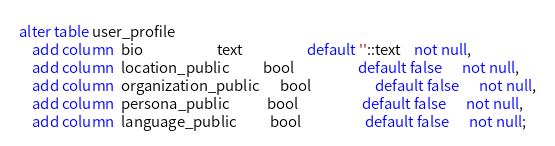<code> <loc_0><loc_0><loc_500><loc_500><_SQL_>alter table user_profile
    add column  bio                      text                   default ''::text    not null,
    add column  location_public          bool                   default false      not null,
    add column  organization_public      bool                   default false      not null,
    add column  persona_public           bool                   default false      not null,
    add column  language_public          bool                   default false      not null;

</code> 